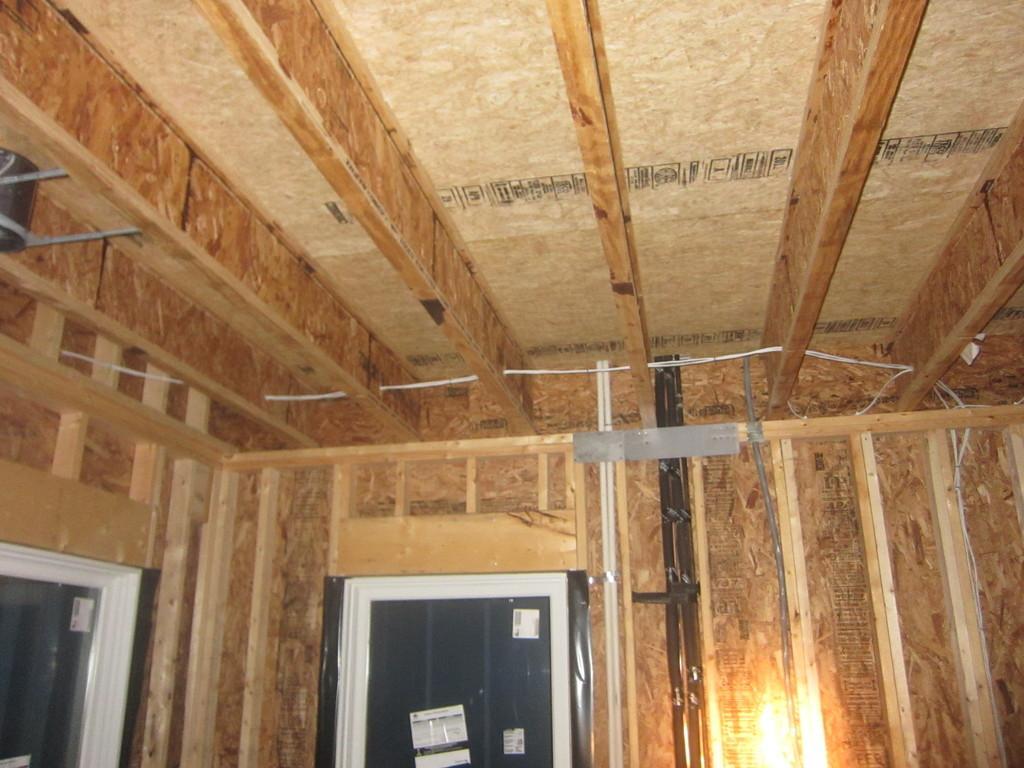Could you give a brief overview of what you see in this image? This is the inside picture of the house. In this image there are doors and there is a light. 